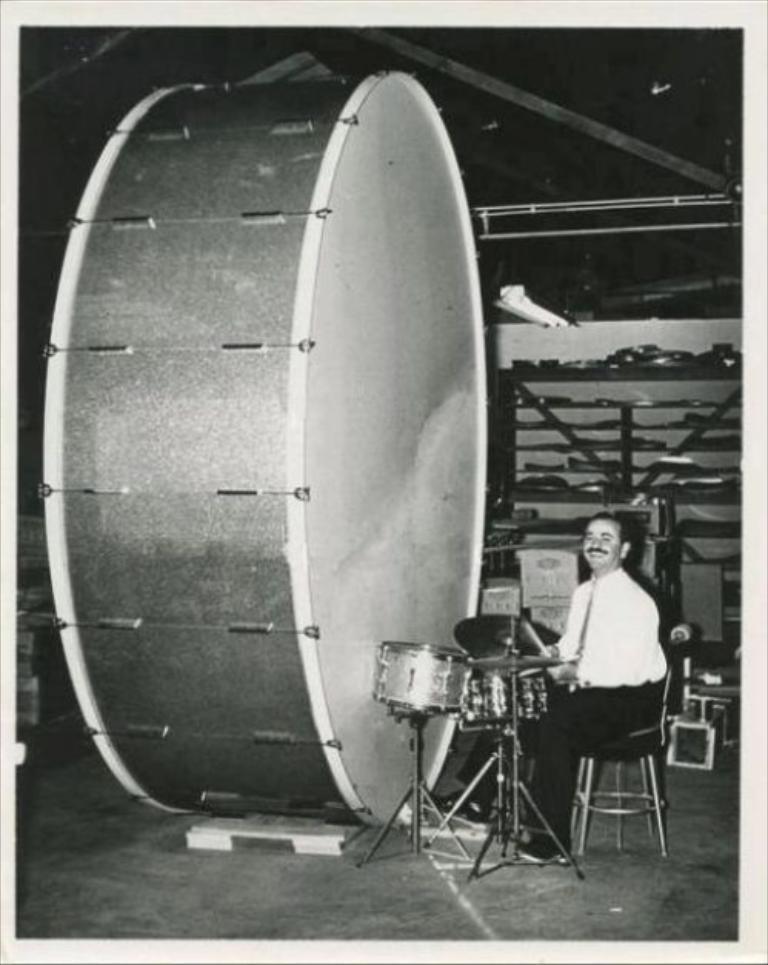Can you describe this image briefly? In this image I can see a person is sitting on the chair and holding something. I can see few musical instruments and few objects. The image is in black and white. 